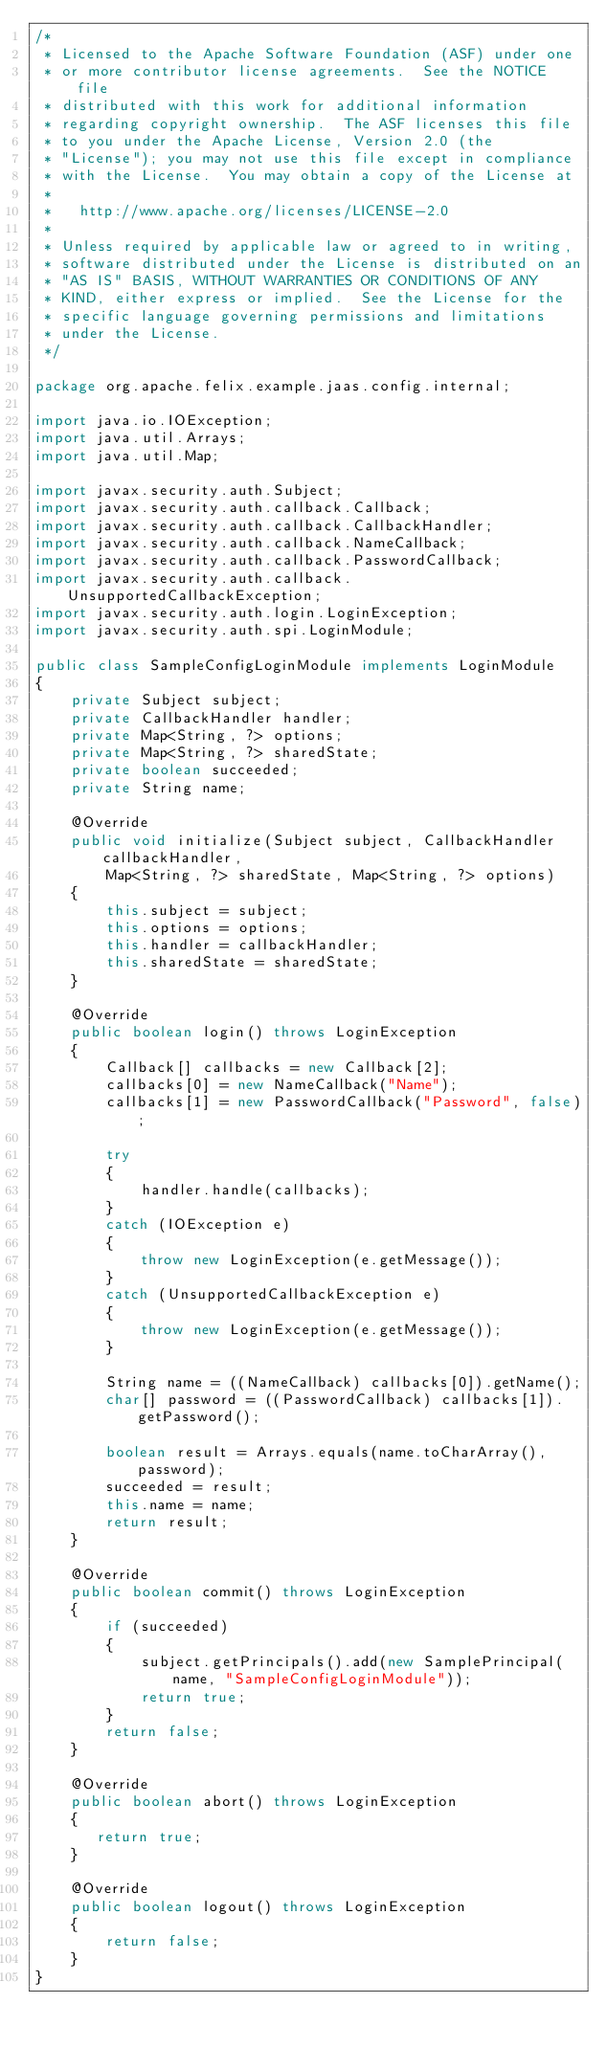Convert code to text. <code><loc_0><loc_0><loc_500><loc_500><_Java_>/*
 * Licensed to the Apache Software Foundation (ASF) under one
 * or more contributor license agreements.  See the NOTICE file
 * distributed with this work for additional information
 * regarding copyright ownership.  The ASF licenses this file
 * to you under the Apache License, Version 2.0 (the
 * "License"); you may not use this file except in compliance
 * with the License.  You may obtain a copy of the License at
 *
 *   http://www.apache.org/licenses/LICENSE-2.0
 *
 * Unless required by applicable law or agreed to in writing,
 * software distributed under the License is distributed on an
 * "AS IS" BASIS, WITHOUT WARRANTIES OR CONDITIONS OF ANY
 * KIND, either express or implied.  See the License for the
 * specific language governing permissions and limitations
 * under the License.
 */

package org.apache.felix.example.jaas.config.internal;

import java.io.IOException;
import java.util.Arrays;
import java.util.Map;

import javax.security.auth.Subject;
import javax.security.auth.callback.Callback;
import javax.security.auth.callback.CallbackHandler;
import javax.security.auth.callback.NameCallback;
import javax.security.auth.callback.PasswordCallback;
import javax.security.auth.callback.UnsupportedCallbackException;
import javax.security.auth.login.LoginException;
import javax.security.auth.spi.LoginModule;

public class SampleConfigLoginModule implements LoginModule
{
    private Subject subject;
    private CallbackHandler handler;
    private Map<String, ?> options;
    private Map<String, ?> sharedState;
    private boolean succeeded;
    private String name;

    @Override
    public void initialize(Subject subject, CallbackHandler callbackHandler,
        Map<String, ?> sharedState, Map<String, ?> options)
    {
        this.subject = subject;
        this.options = options;
        this.handler = callbackHandler;
        this.sharedState = sharedState;
    }

    @Override
    public boolean login() throws LoginException
    {
        Callback[] callbacks = new Callback[2];
        callbacks[0] = new NameCallback("Name");
        callbacks[1] = new PasswordCallback("Password", false);

        try
        {
            handler.handle(callbacks);
        }
        catch (IOException e)
        {
            throw new LoginException(e.getMessage());
        }
        catch (UnsupportedCallbackException e)
        {
            throw new LoginException(e.getMessage());
        }

        String name = ((NameCallback) callbacks[0]).getName();
        char[] password = ((PasswordCallback) callbacks[1]).getPassword();

        boolean result = Arrays.equals(name.toCharArray(), password);
        succeeded = result;
        this.name = name;
        return result;
    }

    @Override
    public boolean commit() throws LoginException
    {
        if (succeeded)
        {
            subject.getPrincipals().add(new SamplePrincipal(name, "SampleConfigLoginModule"));
            return true;
        }
        return false;
    }

    @Override
    public boolean abort() throws LoginException
    {
       return true;
    }

    @Override
    public boolean logout() throws LoginException
    {
        return false;
    }
}
</code> 